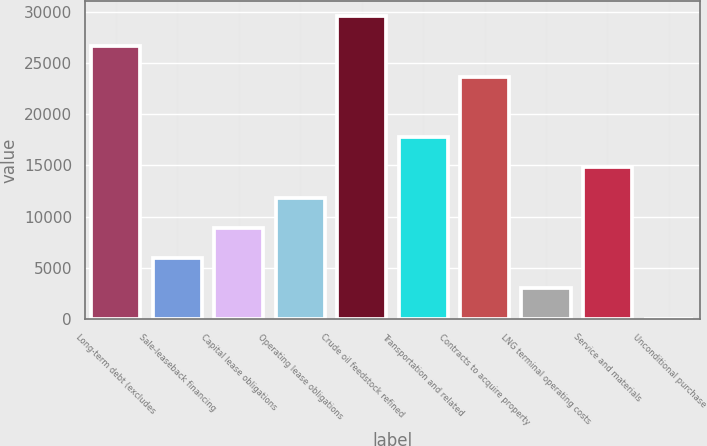Convert chart. <chart><loc_0><loc_0><loc_500><loc_500><bar_chart><fcel>Long-term debt (excludes<fcel>Sale-leaseback financing<fcel>Capital lease obligations<fcel>Operating lease obligations<fcel>Crude oil feedstock refined<fcel>Transportation and related<fcel>Contracts to acquire property<fcel>LNG terminal operating costs<fcel>Service and materials<fcel>Unconditional purchase<nl><fcel>26609<fcel>5952<fcel>8903<fcel>11854<fcel>29560<fcel>17756<fcel>23658<fcel>3001<fcel>14805<fcel>50<nl></chart> 